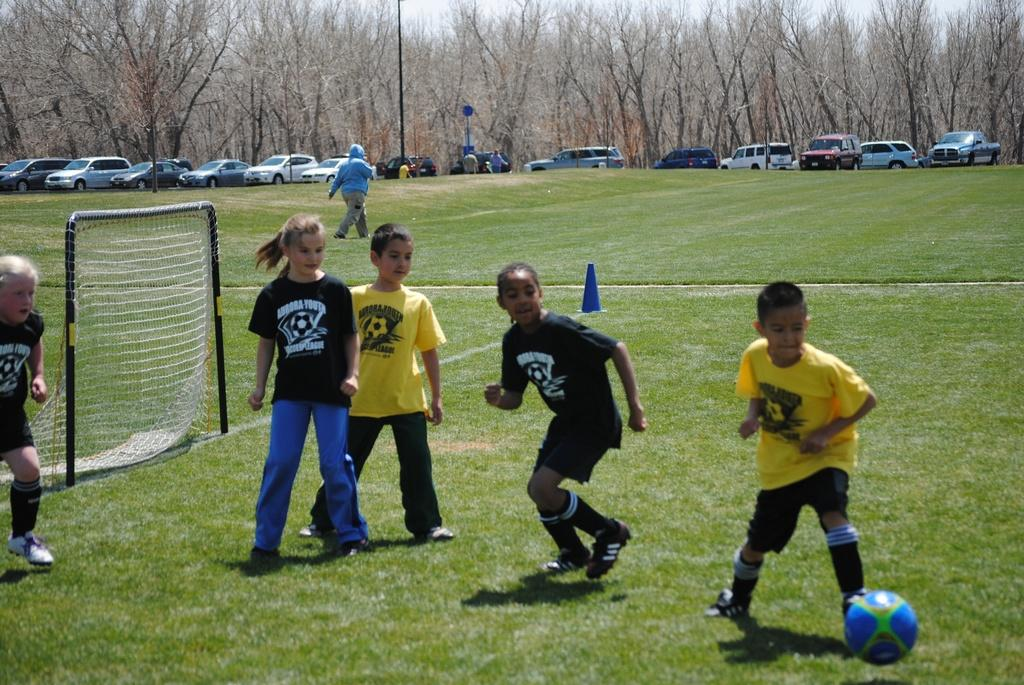How many children are playing football in the image? There are three girls and two boys in the image, making a total of five children playing football. What is the color of the field where the children are playing? The field is green. What structure can be seen in the image related to the game? There is a net in the image. Can you describe the woman's activity in the image? A woman is walking in the image. What else can be seen in the image besides the children playing football? Cars are parked in the image, and trees are present around the area. What type of yarn is the woman using to knit a sweater in the image? There is no woman knitting a sweater in the image; she is simply walking. How many clouds can be seen in the image? There is no mention of clouds in the image; it only describes the presence of a green field, a net, parked cars, and trees. 